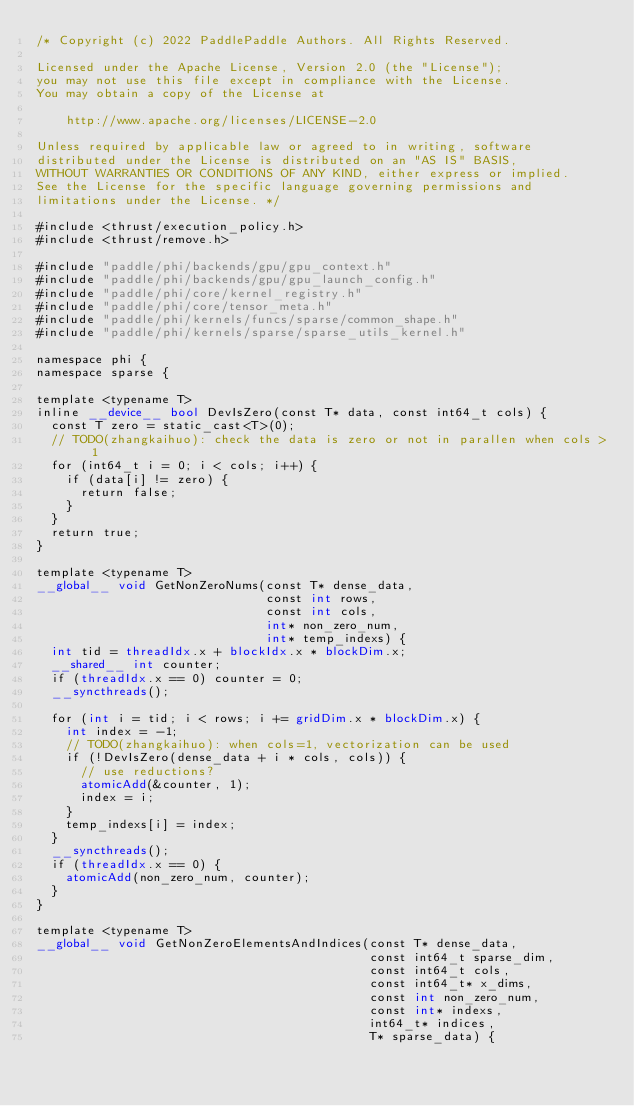Convert code to text. <code><loc_0><loc_0><loc_500><loc_500><_Cuda_>/* Copyright (c) 2022 PaddlePaddle Authors. All Rights Reserved.

Licensed under the Apache License, Version 2.0 (the "License");
you may not use this file except in compliance with the License.
You may obtain a copy of the License at

    http://www.apache.org/licenses/LICENSE-2.0

Unless required by applicable law or agreed to in writing, software
distributed under the License is distributed on an "AS IS" BASIS,
WITHOUT WARRANTIES OR CONDITIONS OF ANY KIND, either express or implied.
See the License for the specific language governing permissions and
limitations under the License. */

#include <thrust/execution_policy.h>
#include <thrust/remove.h>

#include "paddle/phi/backends/gpu/gpu_context.h"
#include "paddle/phi/backends/gpu/gpu_launch_config.h"
#include "paddle/phi/core/kernel_registry.h"
#include "paddle/phi/core/tensor_meta.h"
#include "paddle/phi/kernels/funcs/sparse/common_shape.h"
#include "paddle/phi/kernels/sparse/sparse_utils_kernel.h"

namespace phi {
namespace sparse {

template <typename T>
inline __device__ bool DevIsZero(const T* data, const int64_t cols) {
  const T zero = static_cast<T>(0);
  // TODO(zhangkaihuo): check the data is zero or not in parallen when cols > 1
  for (int64_t i = 0; i < cols; i++) {
    if (data[i] != zero) {
      return false;
    }
  }
  return true;
}

template <typename T>
__global__ void GetNonZeroNums(const T* dense_data,
                               const int rows,
                               const int cols,
                               int* non_zero_num,
                               int* temp_indexs) {
  int tid = threadIdx.x + blockIdx.x * blockDim.x;
  __shared__ int counter;
  if (threadIdx.x == 0) counter = 0;
  __syncthreads();

  for (int i = tid; i < rows; i += gridDim.x * blockDim.x) {
    int index = -1;
    // TODO(zhangkaihuo): when cols=1, vectorization can be used
    if (!DevIsZero(dense_data + i * cols, cols)) {
      // use reductions?
      atomicAdd(&counter, 1);
      index = i;
    }
    temp_indexs[i] = index;
  }
  __syncthreads();
  if (threadIdx.x == 0) {
    atomicAdd(non_zero_num, counter);
  }
}

template <typename T>
__global__ void GetNonZeroElementsAndIndices(const T* dense_data,
                                             const int64_t sparse_dim,
                                             const int64_t cols,
                                             const int64_t* x_dims,
                                             const int non_zero_num,
                                             const int* indexs,
                                             int64_t* indices,
                                             T* sparse_data) {</code> 